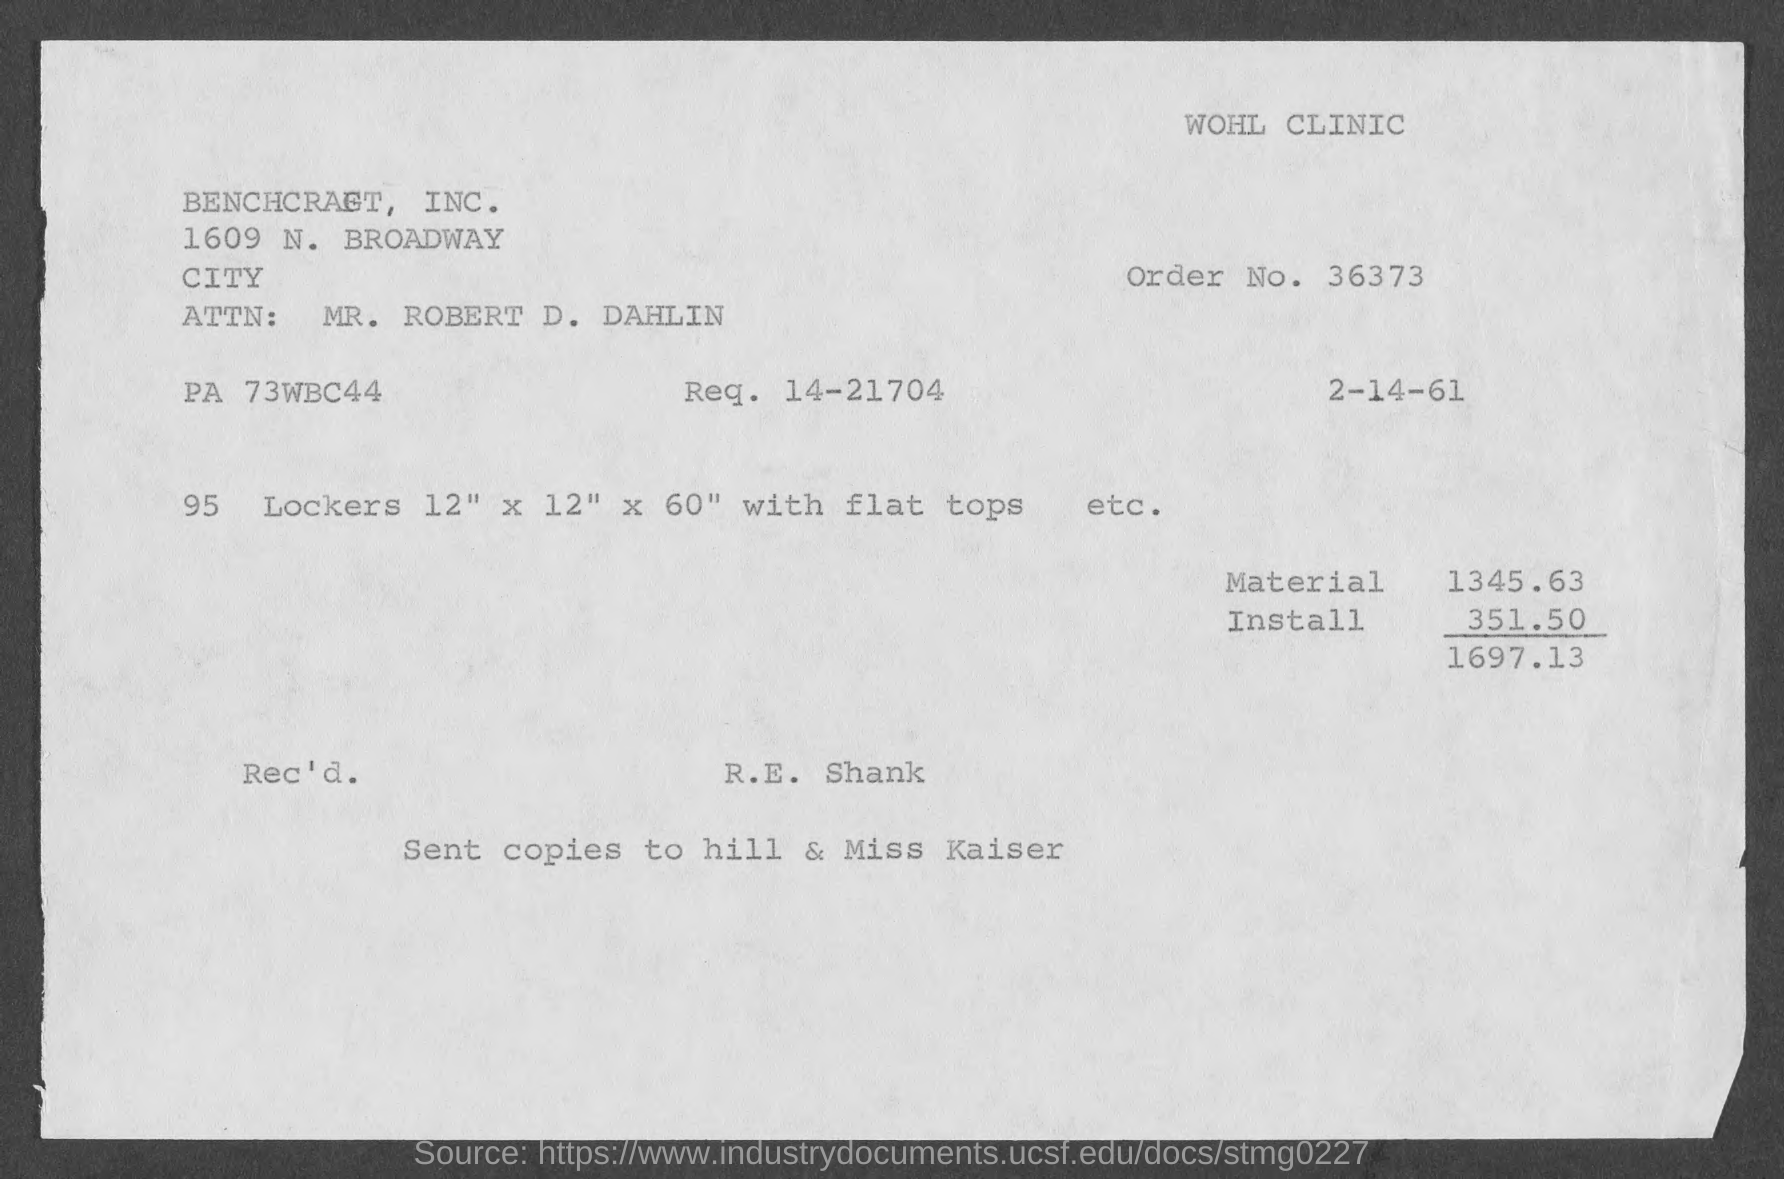List a handful of essential elements in this visual. What is Req. no. 14-21704?" is a question that asks for information about a specific request number. The total amount of the order is $1697.13. Copies of the letter are sent to Hill and Miss Kaiser. 